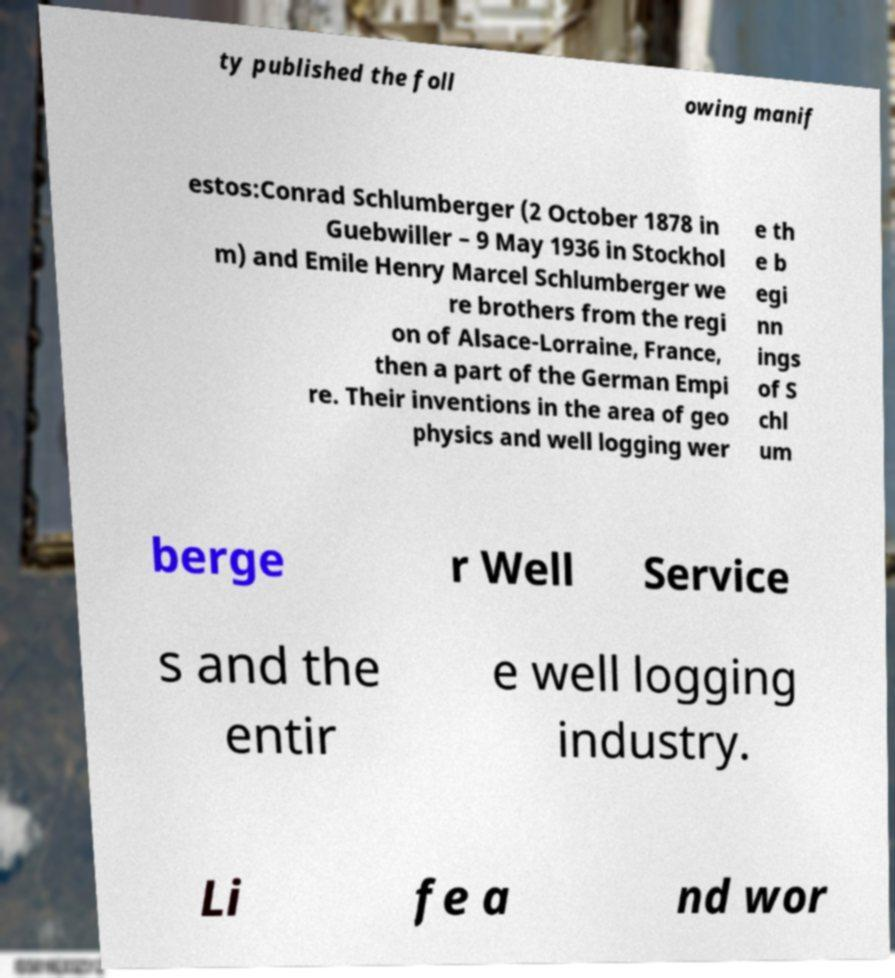Can you read and provide the text displayed in the image?This photo seems to have some interesting text. Can you extract and type it out for me? ty published the foll owing manif estos:Conrad Schlumberger (2 October 1878 in Guebwiller – 9 May 1936 in Stockhol m) and Emile Henry Marcel Schlumberger we re brothers from the regi on of Alsace-Lorraine, France, then a part of the German Empi re. Their inventions in the area of geo physics and well logging wer e th e b egi nn ings of S chl um berge r Well Service s and the entir e well logging industry. Li fe a nd wor 